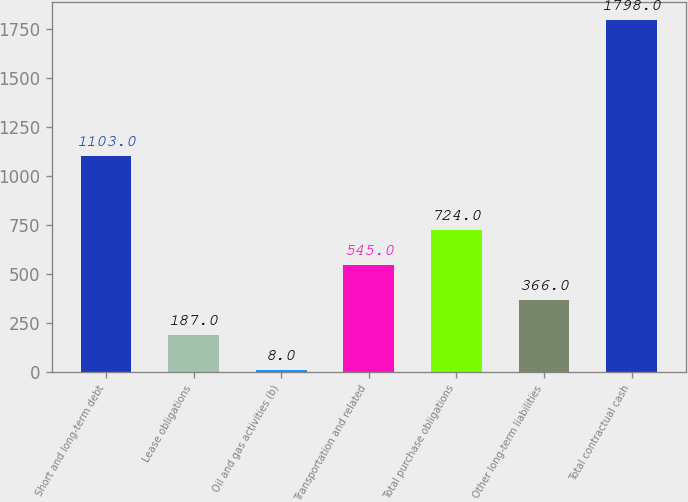<chart> <loc_0><loc_0><loc_500><loc_500><bar_chart><fcel>Short and long-term debt<fcel>Lease obligations<fcel>Oil and gas activities (b)<fcel>Transportation and related<fcel>Total purchase obligations<fcel>Other long-term liabilities<fcel>Total contractual cash<nl><fcel>1103<fcel>187<fcel>8<fcel>545<fcel>724<fcel>366<fcel>1798<nl></chart> 